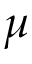<formula> <loc_0><loc_0><loc_500><loc_500>\mu</formula> 